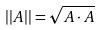<formula> <loc_0><loc_0><loc_500><loc_500>| | A | | = \sqrt { A \cdot A }</formula> 